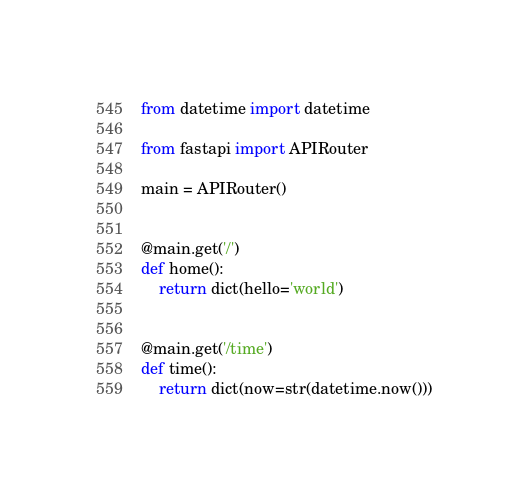<code> <loc_0><loc_0><loc_500><loc_500><_Python_>from datetime import datetime

from fastapi import APIRouter

main = APIRouter()


@main.get('/')
def home():
    return dict(hello='world')


@main.get('/time')
def time():
    return dict(now=str(datetime.now()))
</code> 